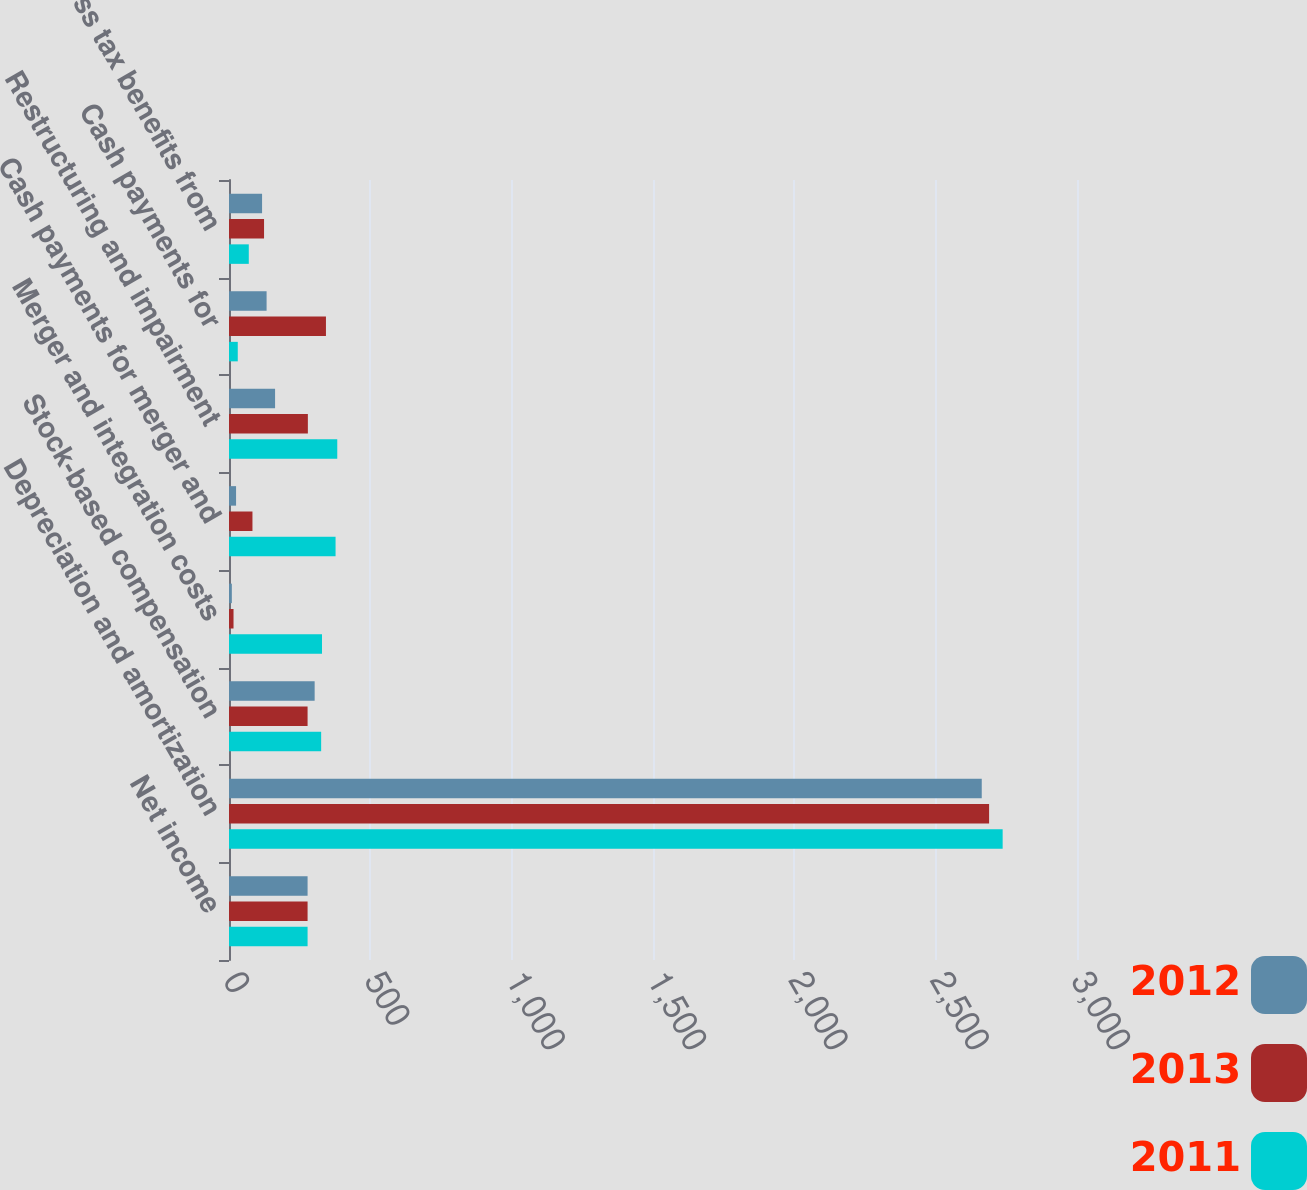Convert chart. <chart><loc_0><loc_0><loc_500><loc_500><stacked_bar_chart><ecel><fcel>Net income<fcel>Depreciation and amortization<fcel>Stock-based compensation<fcel>Merger and integration costs<fcel>Cash payments for merger and<fcel>Restructuring and impairment<fcel>Cash payments for<fcel>Excess tax benefits from<nl><fcel>2012<fcel>278<fcel>2663<fcel>303<fcel>10<fcel>25<fcel>163<fcel>133<fcel>117<nl><fcel>2013<fcel>278<fcel>2689<fcel>278<fcel>16<fcel>83<fcel>279<fcel>343<fcel>124<nl><fcel>2011<fcel>278<fcel>2737<fcel>326<fcel>329<fcel>377<fcel>383<fcel>31<fcel>70<nl></chart> 